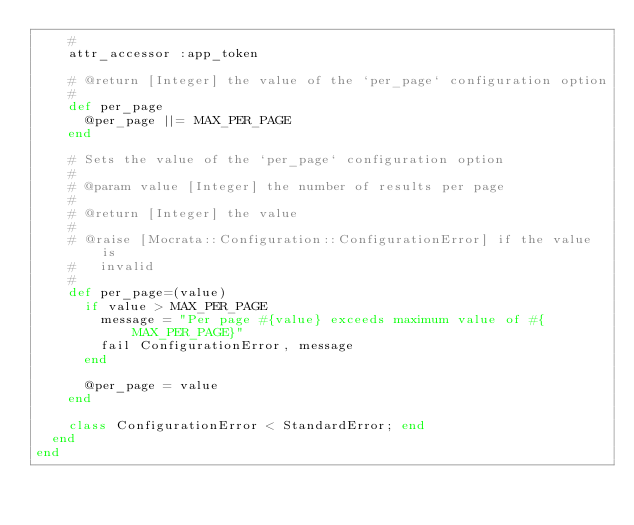<code> <loc_0><loc_0><loc_500><loc_500><_Ruby_>    #
    attr_accessor :app_token

    # @return [Integer] the value of the `per_page` configuration option
    #
    def per_page
      @per_page ||= MAX_PER_PAGE
    end

    # Sets the value of the `per_page` configuration option
    #
    # @param value [Integer] the number of results per page
    #
    # @return [Integer] the value
    #
    # @raise [Mocrata::Configuration::ConfigurationError] if the value is
    #   invalid
    #
    def per_page=(value)
      if value > MAX_PER_PAGE
        message = "Per page #{value} exceeds maximum value of #{MAX_PER_PAGE}"
        fail ConfigurationError, message
      end

      @per_page = value
    end

    class ConfigurationError < StandardError; end
  end
end
</code> 